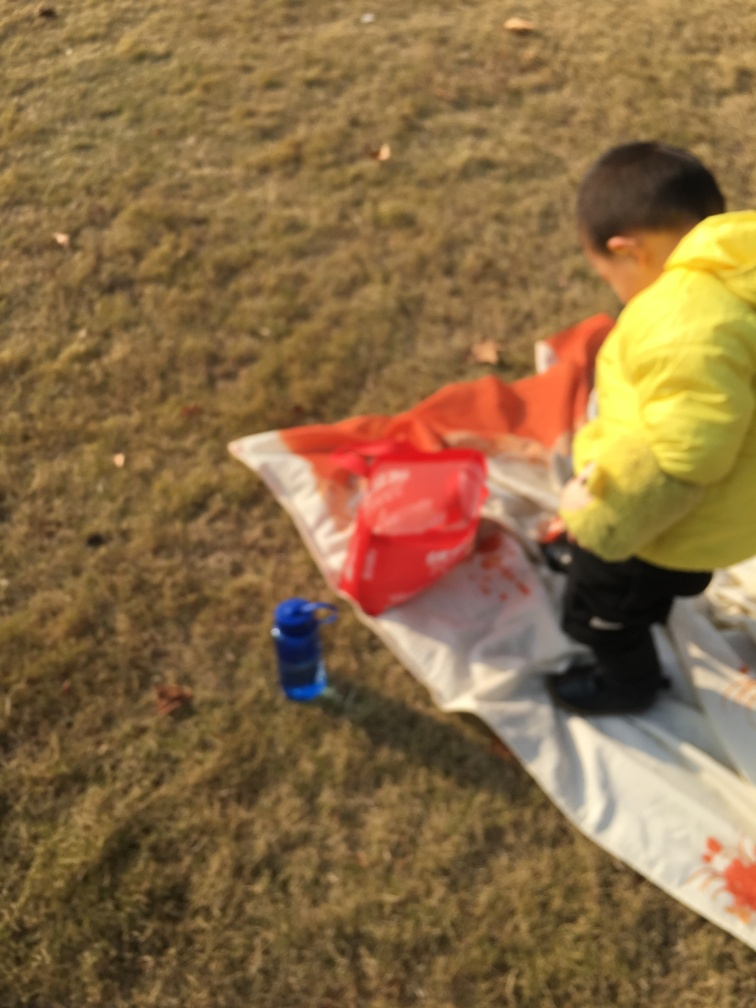Are the texture and details of the child visible? Due to the image being out of focus, it is challenging to discern the precise texture and details of the child's attire and features. However, I can provide some information based on visible elements such as the colors and broader shapes. 